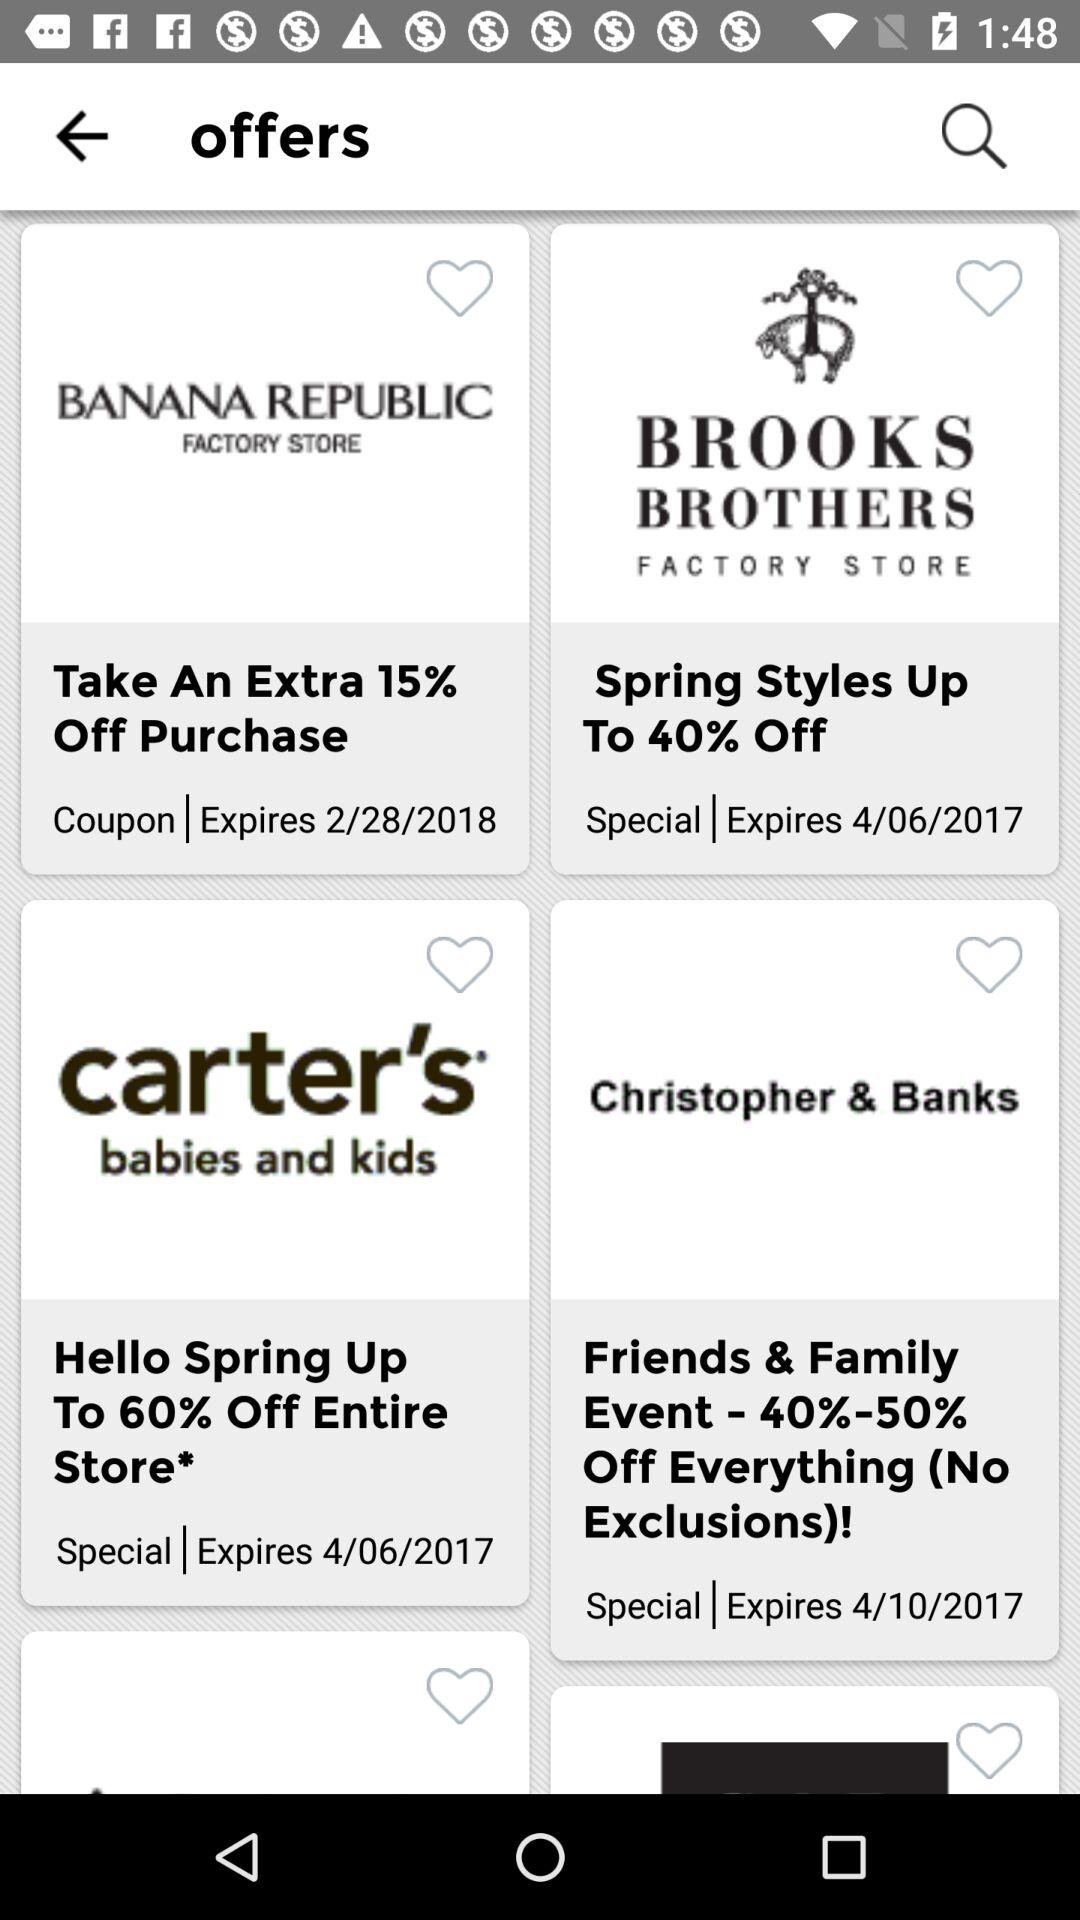What is the expiration date of the offer at the "BANANA REPUBLIC FACTORY STORE"? The expiration date is February 28, 2018. 